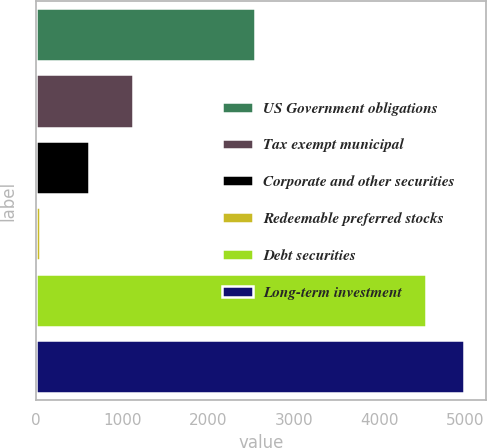<chart> <loc_0><loc_0><loc_500><loc_500><bar_chart><fcel>US Government obligations<fcel>Tax exempt municipal<fcel>Corporate and other securities<fcel>Redeemable preferred stocks<fcel>Debt securities<fcel>Long-term investment<nl><fcel>2542<fcel>1123<fcel>617<fcel>49<fcel>4537<fcel>4985.8<nl></chart> 